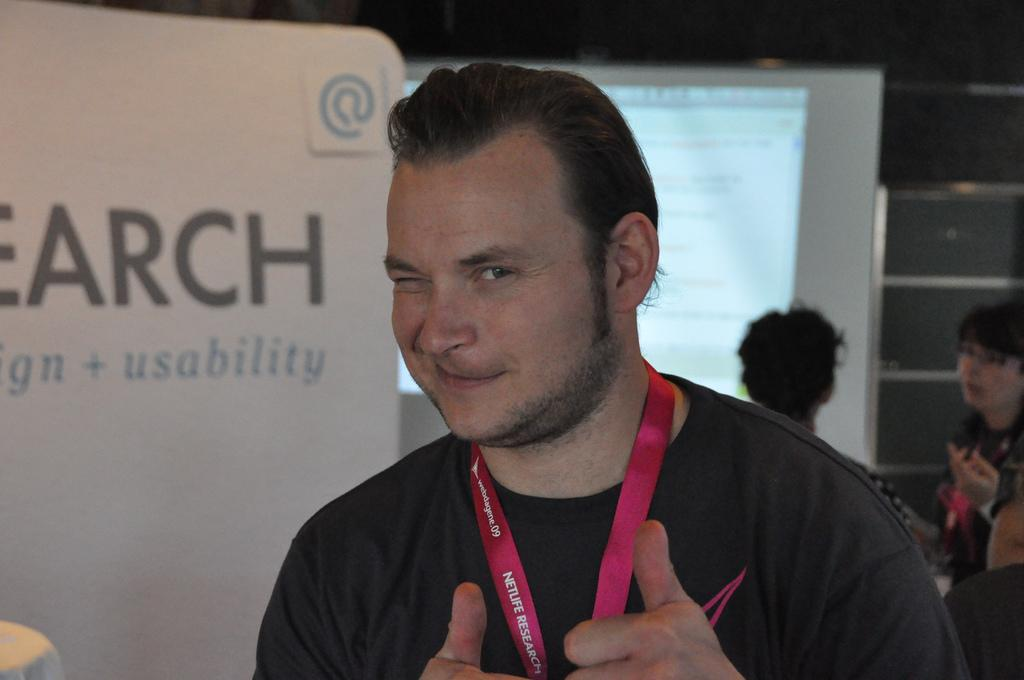What is the person in the image wearing on their upper body? The person in the image is wearing a black color shirt. What color is the tag that the person is wearing? The person is wearing a red color tag. Can you describe the people in the background of the image? There are other persons standing at the back of the image. What color is the banner visible in the image? There is a banner in white color in the image. How many balls are being juggled by the person in the image? There are no balls visible in the image; the person is not juggling anything. 